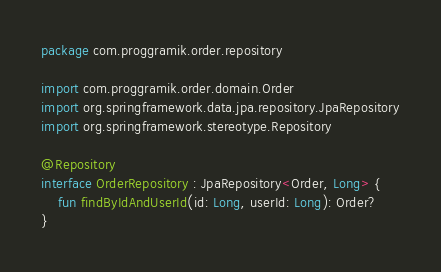<code> <loc_0><loc_0><loc_500><loc_500><_Kotlin_>package com.proggramik.order.repository

import com.proggramik.order.domain.Order
import org.springframework.data.jpa.repository.JpaRepository
import org.springframework.stereotype.Repository

@Repository
interface OrderRepository : JpaRepository<Order, Long> {
    fun findByIdAndUserId(id: Long, userId: Long): Order?
}
</code> 